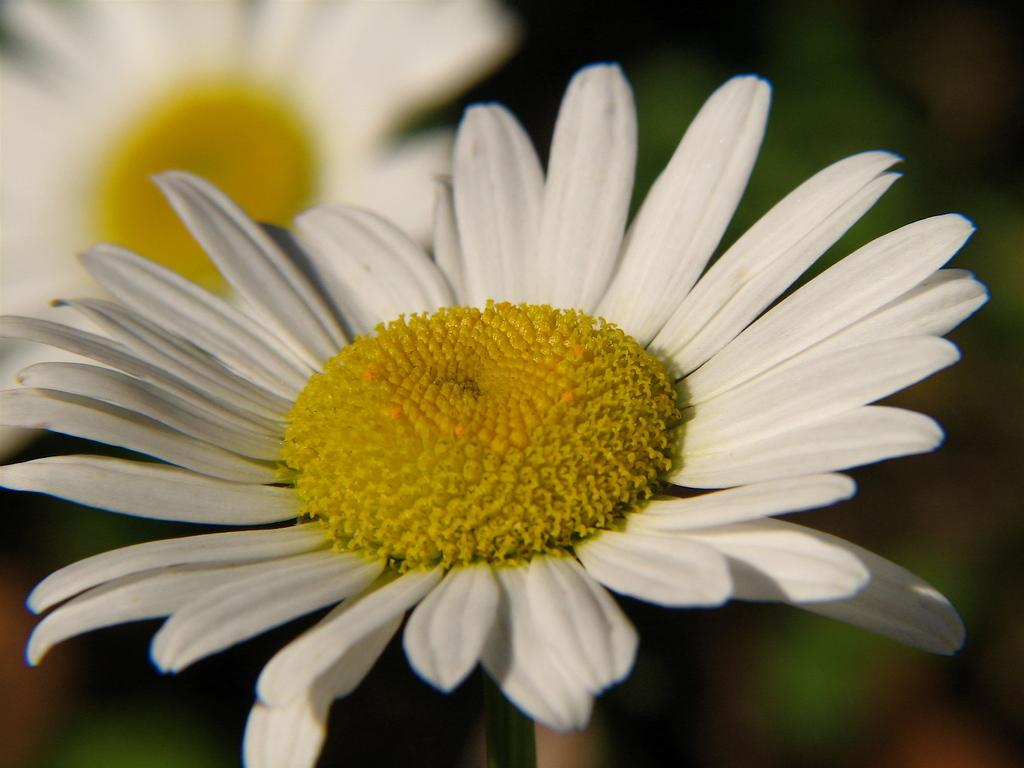What colors of flowers can be seen in the image? There are white and yellow color flowers in the image. Can you describe the background of the image? The background of the image is blurred. What type of skirt is being worn by the lamp in the image? There is no skirt or lamp present in the image; it features flowers and a blurred background. 